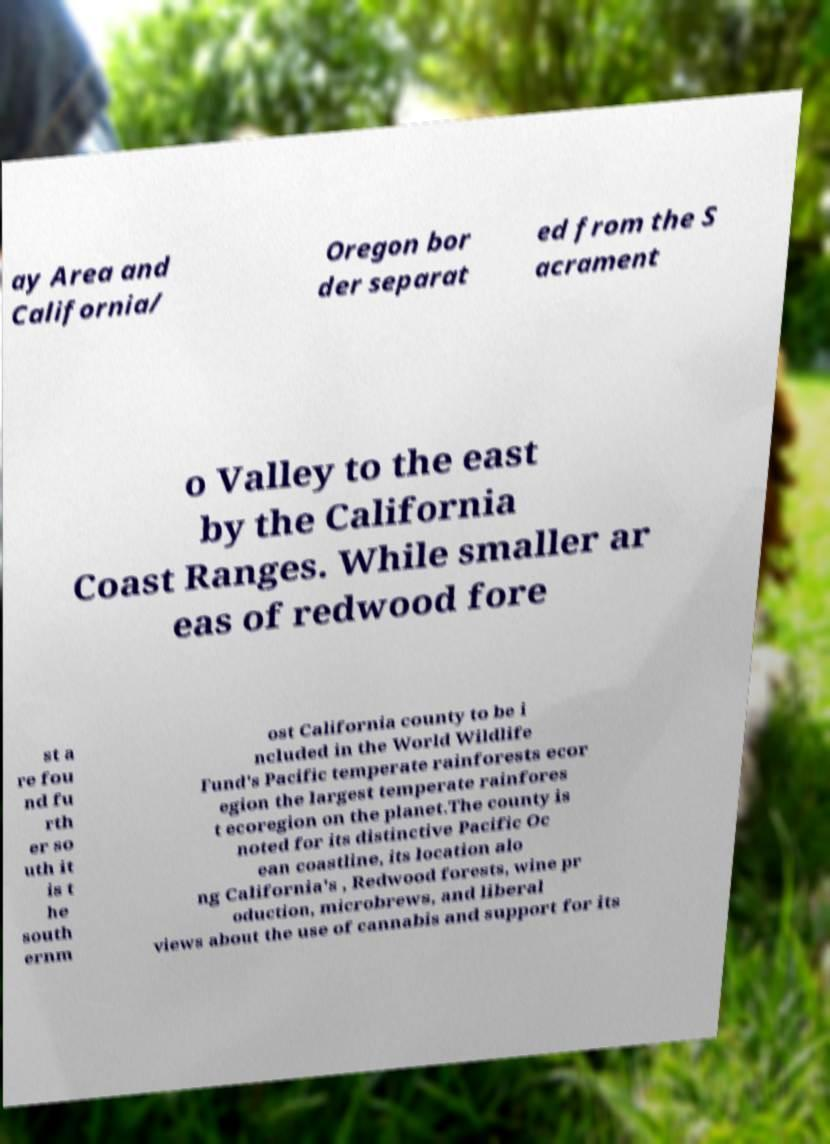Please read and relay the text visible in this image. What does it say? ay Area and California/ Oregon bor der separat ed from the S acrament o Valley to the east by the California Coast Ranges. While smaller ar eas of redwood fore st a re fou nd fu rth er so uth it is t he south ernm ost California county to be i ncluded in the World Wildlife Fund's Pacific temperate rainforests ecor egion the largest temperate rainfores t ecoregion on the planet.The county is noted for its distinctive Pacific Oc ean coastline, its location alo ng California's , Redwood forests, wine pr oduction, microbrews, and liberal views about the use of cannabis and support for its 